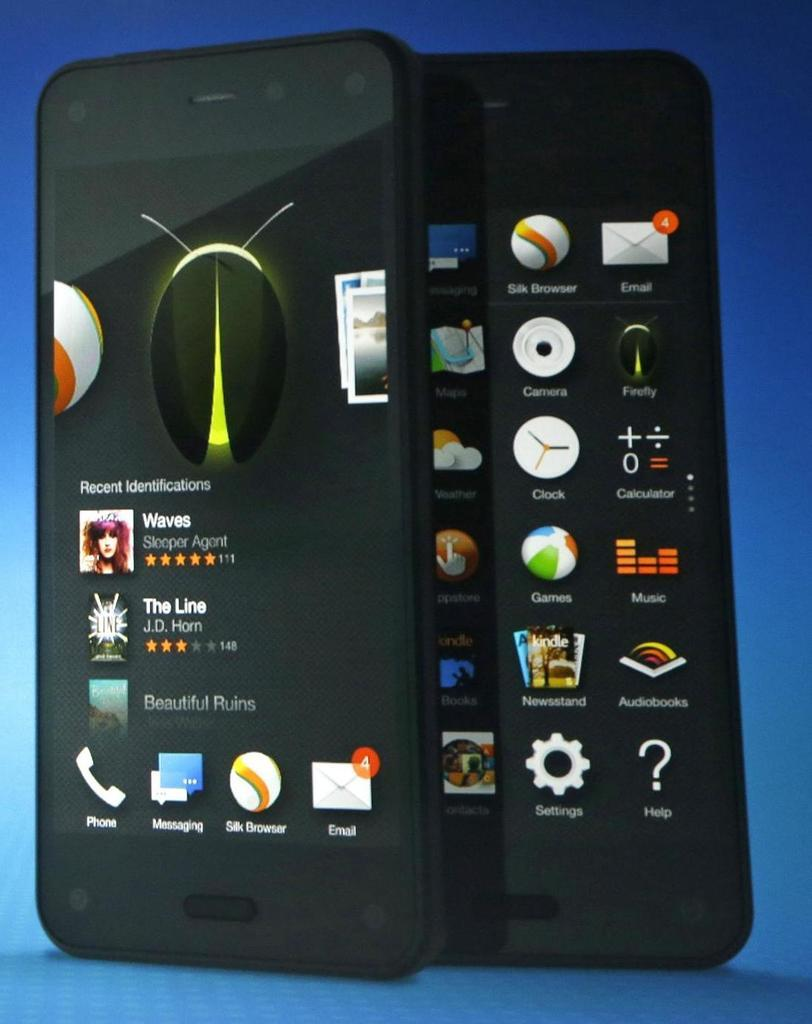<image>
Share a concise interpretation of the image provided. A cell phone with apps such as Calculator and Email. 